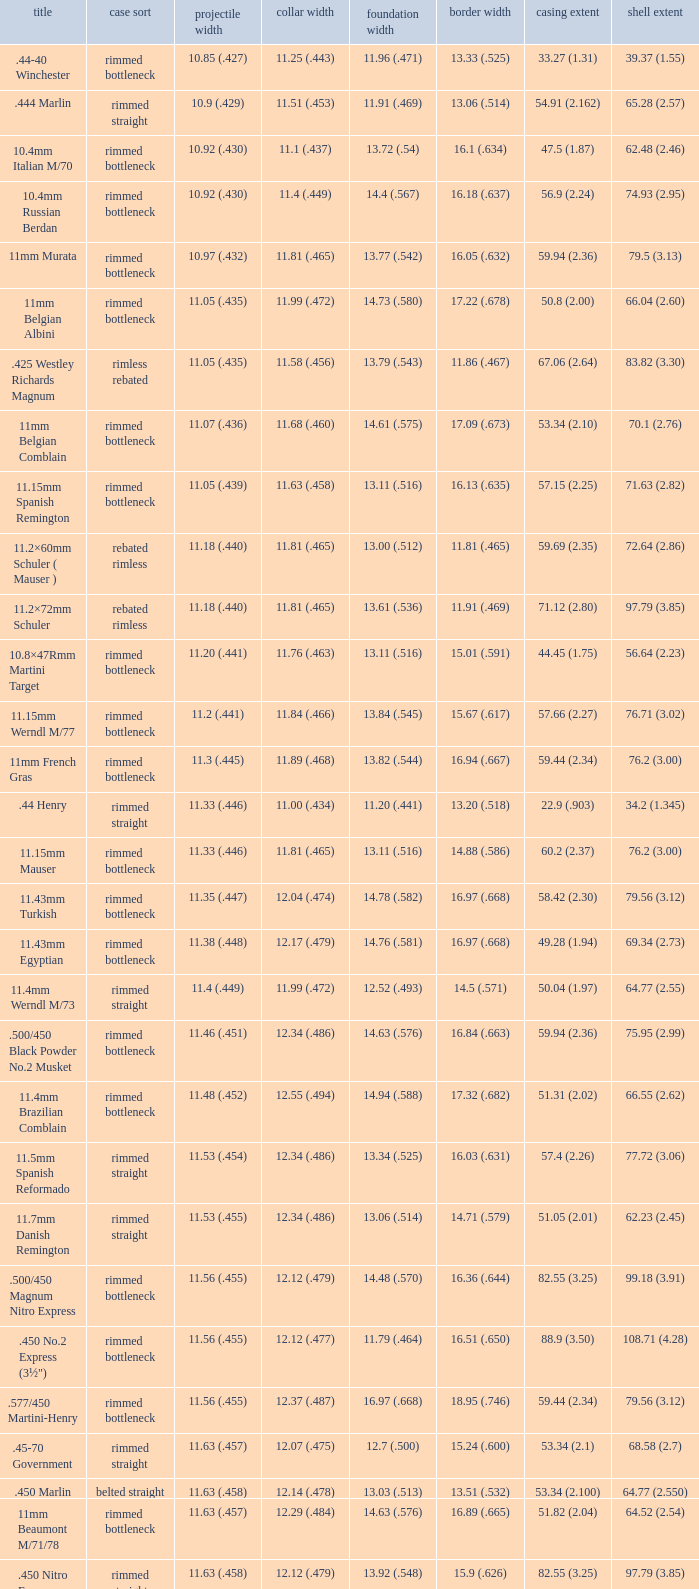Which Case type has a Base diameter of 13.03 (.513), and a Case length of 63.5 (2.5)? Belted straight. 